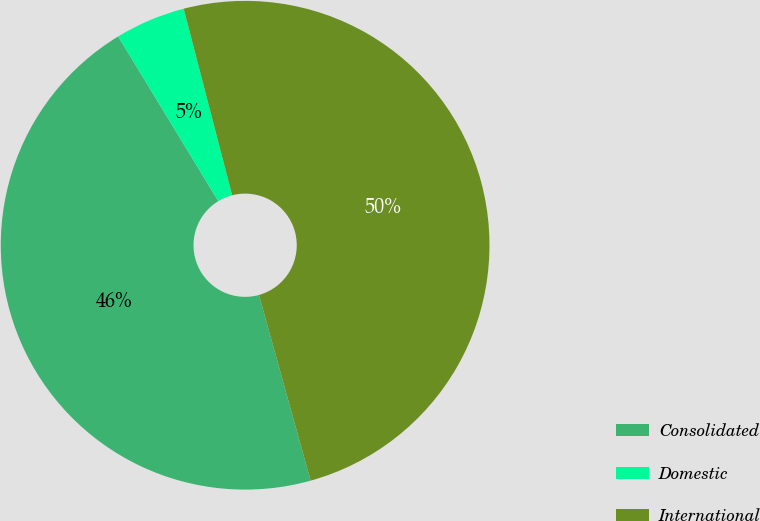Convert chart. <chart><loc_0><loc_0><loc_500><loc_500><pie_chart><fcel>Consolidated<fcel>Domestic<fcel>International<nl><fcel>45.62%<fcel>4.65%<fcel>49.72%<nl></chart> 